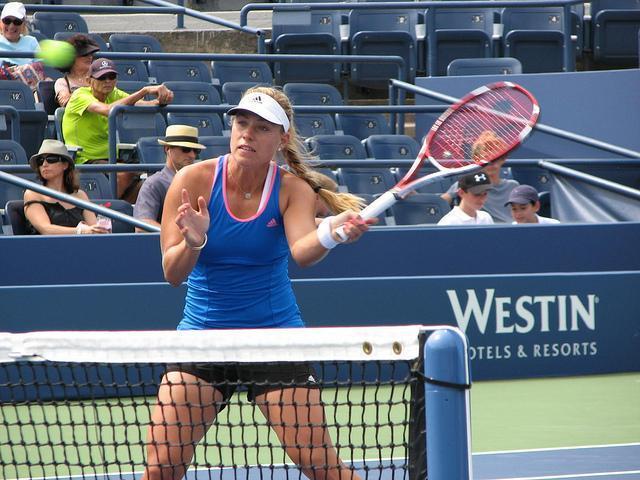How many chairs are there?
Give a very brief answer. 3. How many people are in the picture?
Give a very brief answer. 6. 